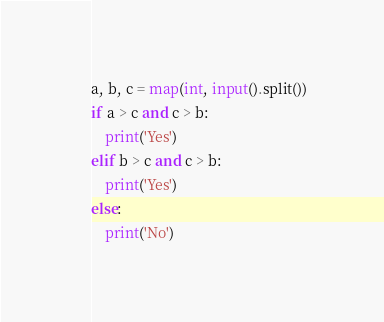<code> <loc_0><loc_0><loc_500><loc_500><_Python_>a, b, c = map(int, input().split())
if a > c and c > b:
    print('Yes')
elif b > c and c > b:
    print('Yes')
else:
    print('No')
</code> 